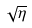<formula> <loc_0><loc_0><loc_500><loc_500>\sqrt { \eta }</formula> 